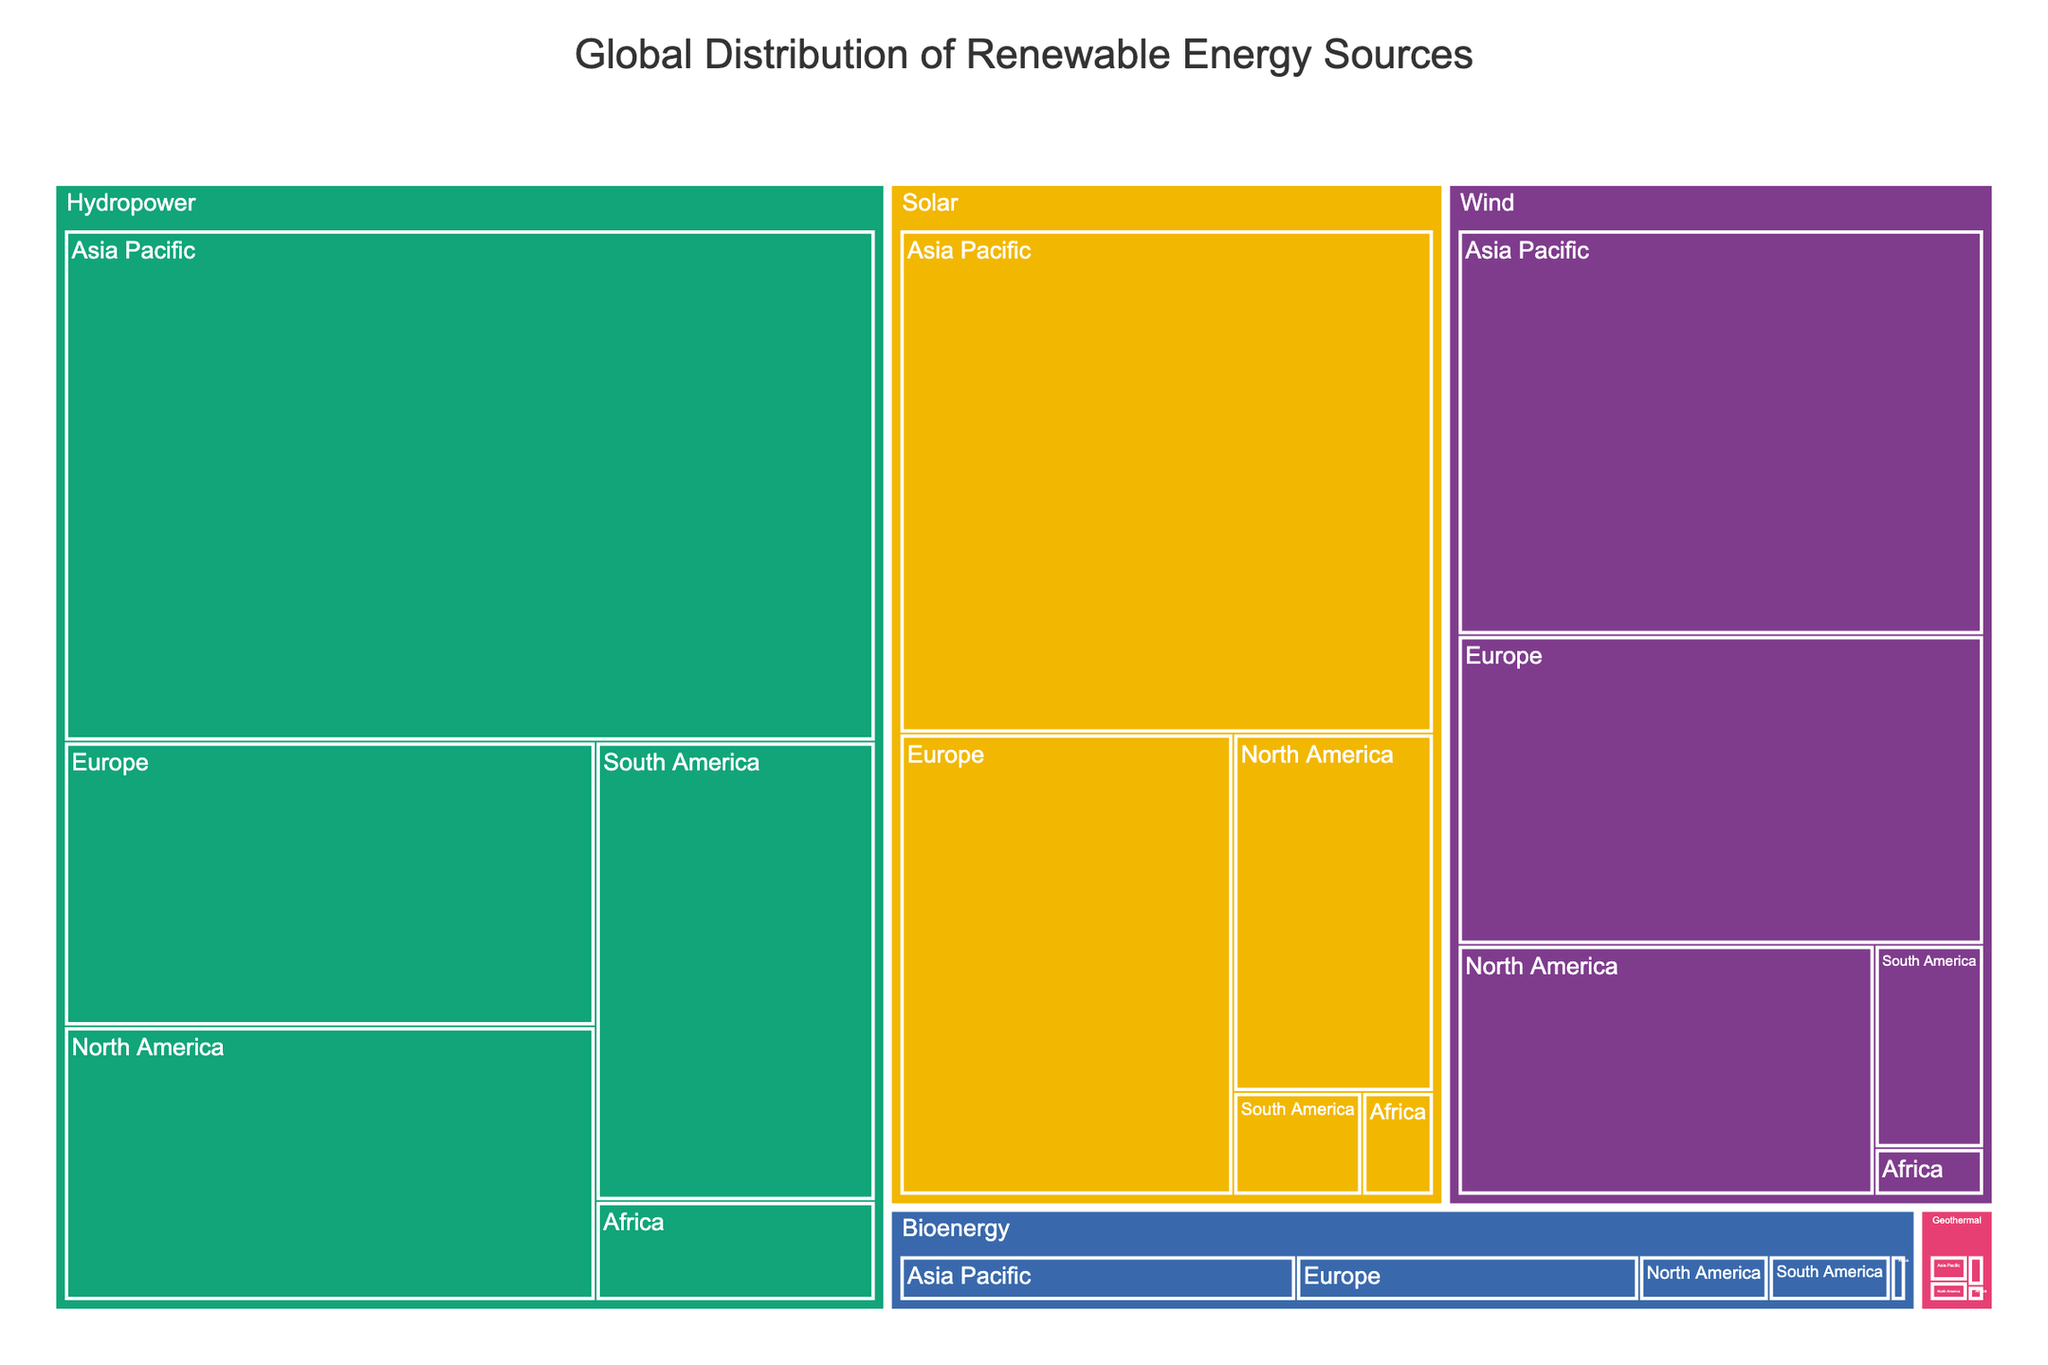What's the title of the figure? The title is usually displayed prominently at the top of the chart. In this case, it provides a summary of the data visualized in the treemap.
Answer: Global Distribution of Renewable Energy Sources Which renewable energy type has the highest capacity in Asia Pacific? To find this, locate the Asia Pacific region in the treemap and identify the renewable energy type with the largest area.
Answer: Hydropower What is the combined capacity of solar energy in Europe and North America? Sum the capacities of solar energy in Europe (208 GW) and North America (97 GW). 208 GW + 97 GW = 305 GW
Answer: 305 GW Which region has the smallest capacity for geothermal energy? Look for the smallest section within the geothermal category and identify its region.
Answer: Africa Compare the capacities of wind energy in North America and South America. Which is larger? Locate the sections for wind energy in North America and South America. Compare the size and value of the capacities: North America (141 GW) vs. South America (30 GW).
Answer: North America Among the renewable energy types, which has the least overall global capacity? Identify the renewable energy type with the smallest total area in the treemap.
Answer: Geothermal What is the total capacity of hydropower in Europe, North America, and South America combined? Sum the capacities for hydropower in Europe (200 GW), North America (193 GW), and South America (170 GW). 200 GW + 193 GW + 170 GW = 563 GW
Answer: 563 GW How does the capacity of bioenergy in Africa compare to that in Europe? Compare the sizes and values of the bioenergy sections in Africa (2 GW) and Europe (45 GW).
Answer: Europe has a larger capacity Identify the renewable energy type and region pair with a capacity of 97 GW. Find the section labeled with 97 GW and identify its renewable energy type and region.
Answer: Solar, North America Which renewable energy type in Europe has the highest capacity? Look within the sections for Europe and identify the renewable energy type with the largest area.
Answer: Wind 